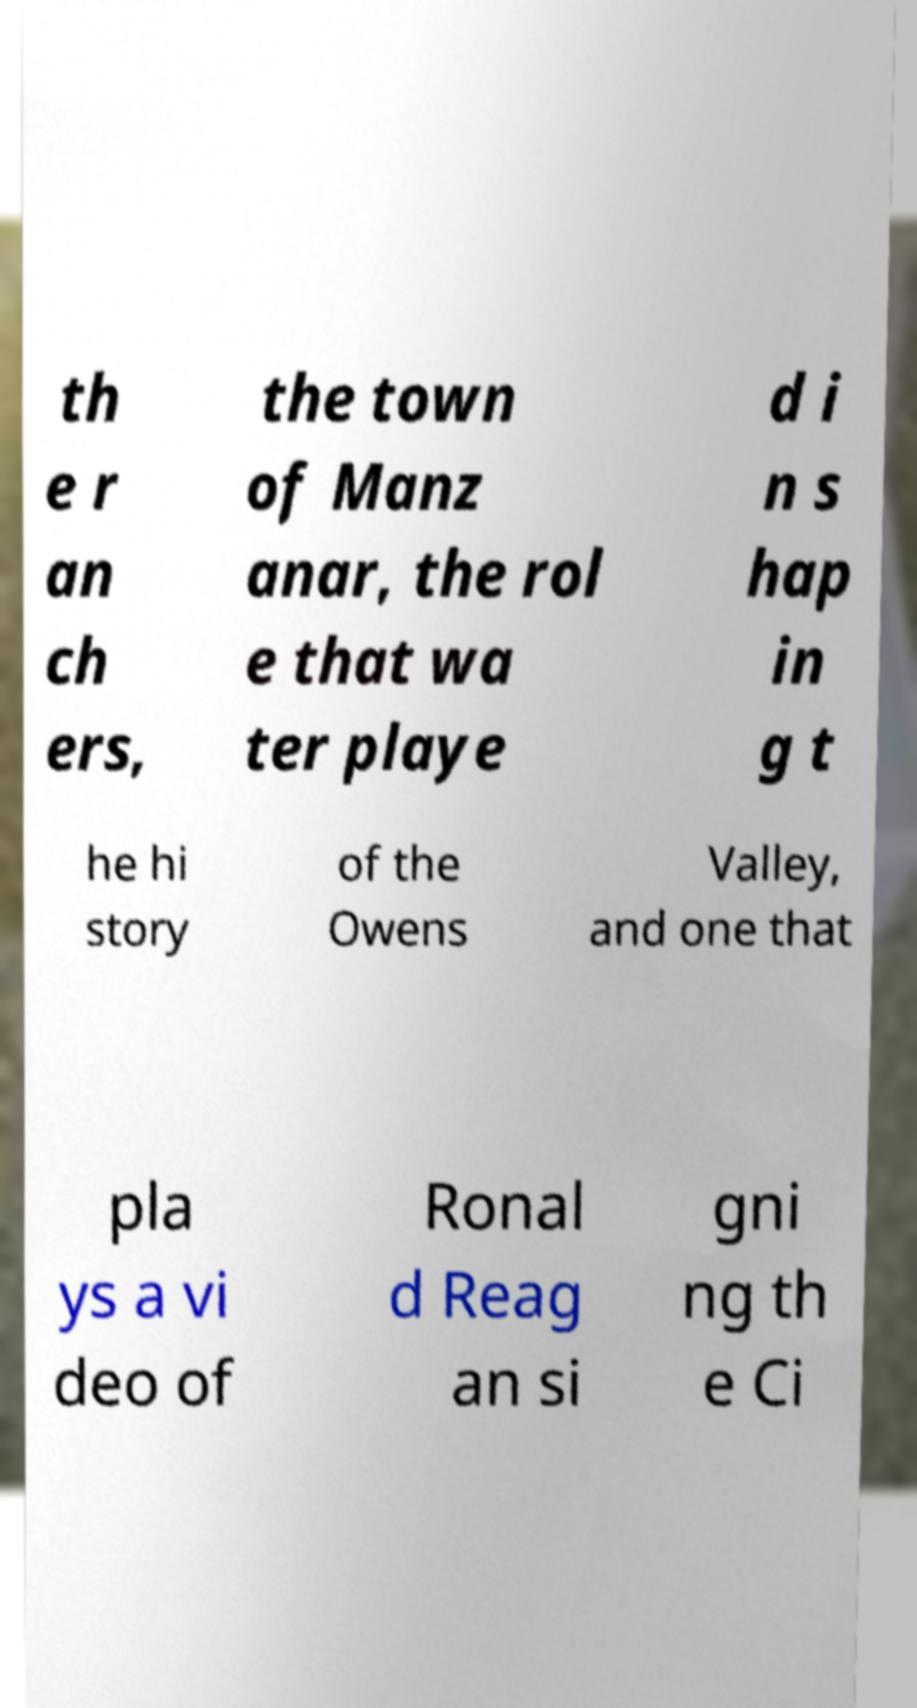For documentation purposes, I need the text within this image transcribed. Could you provide that? th e r an ch ers, the town of Manz anar, the rol e that wa ter playe d i n s hap in g t he hi story of the Owens Valley, and one that pla ys a vi deo of Ronal d Reag an si gni ng th e Ci 